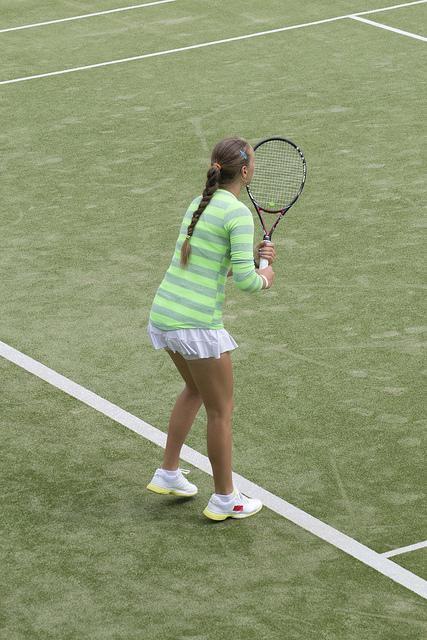How many hands are holding the tennis racket?
Give a very brief answer. 2. 